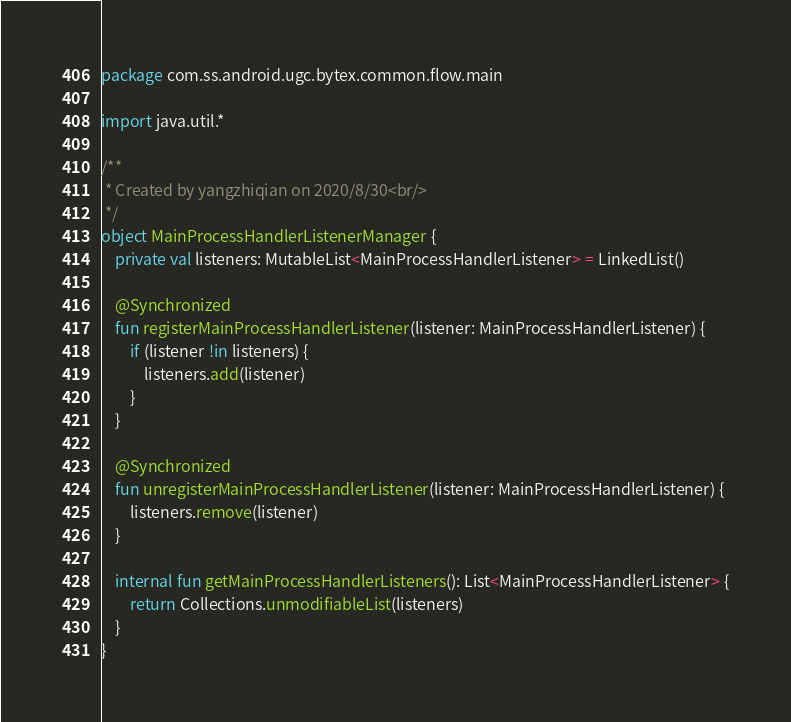<code> <loc_0><loc_0><loc_500><loc_500><_Kotlin_>package com.ss.android.ugc.bytex.common.flow.main

import java.util.*

/**
 * Created by yangzhiqian on 2020/8/30<br/>
 */
object MainProcessHandlerListenerManager {
    private val listeners: MutableList<MainProcessHandlerListener> = LinkedList()

    @Synchronized
    fun registerMainProcessHandlerListener(listener: MainProcessHandlerListener) {
        if (listener !in listeners) {
            listeners.add(listener)
        }
    }

    @Synchronized
    fun unregisterMainProcessHandlerListener(listener: MainProcessHandlerListener) {
        listeners.remove(listener)
    }

    internal fun getMainProcessHandlerListeners(): List<MainProcessHandlerListener> {
        return Collections.unmodifiableList(listeners)
    }
}</code> 